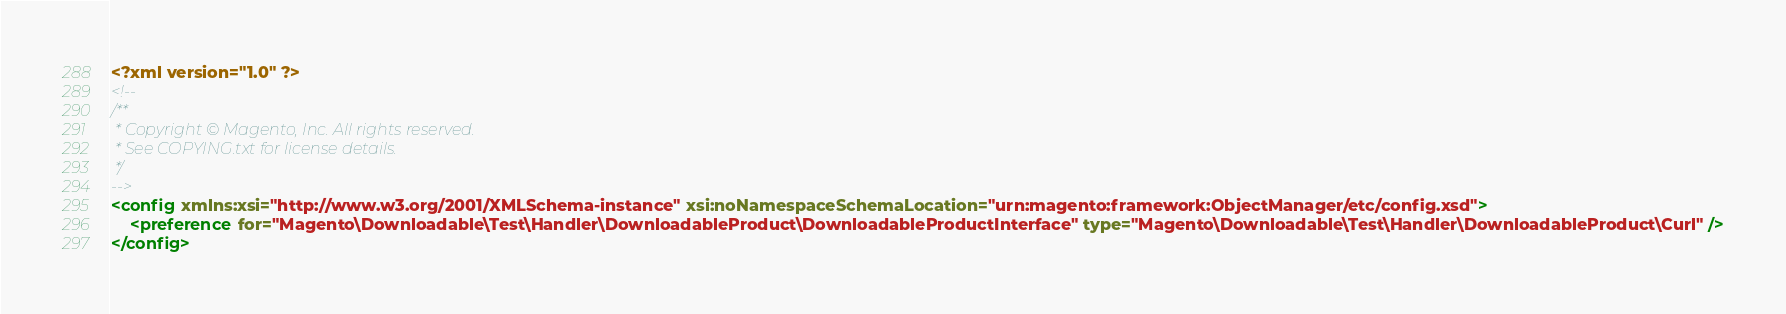<code> <loc_0><loc_0><loc_500><loc_500><_XML_><?xml version="1.0" ?>
<!--
/**
 * Copyright © Magento, Inc. All rights reserved.
 * See COPYING.txt for license details.
 */
-->
<config xmlns:xsi="http://www.w3.org/2001/XMLSchema-instance" xsi:noNamespaceSchemaLocation="urn:magento:framework:ObjectManager/etc/config.xsd">
    <preference for="Magento\Downloadable\Test\Handler\DownloadableProduct\DownloadableProductInterface" type="Magento\Downloadable\Test\Handler\DownloadableProduct\Curl" />
</config>
</code> 